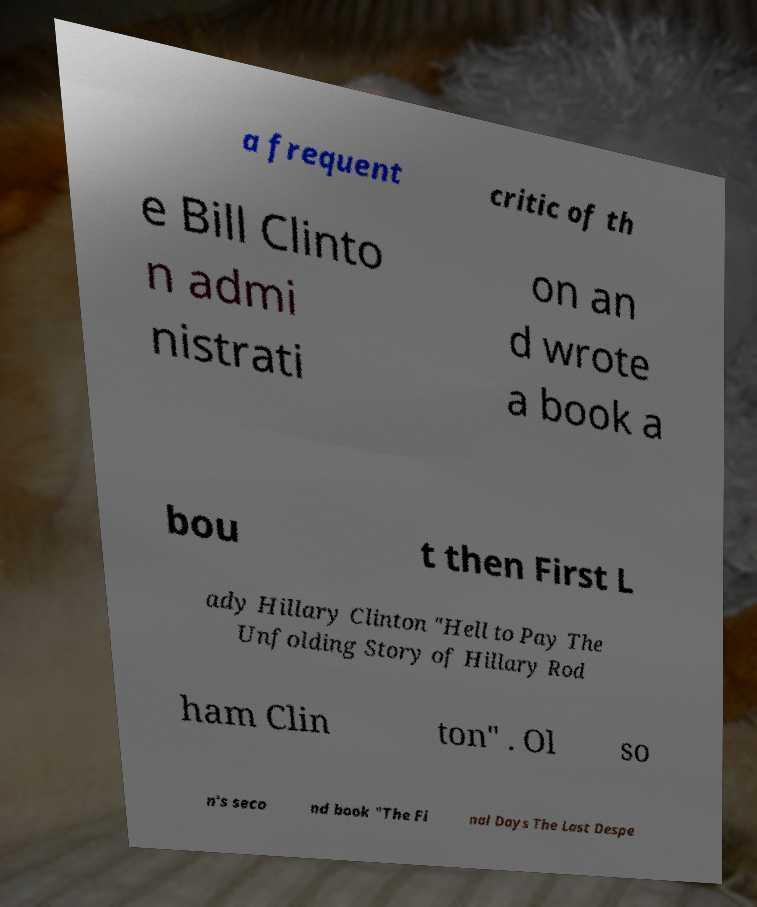Could you extract and type out the text from this image? a frequent critic of th e Bill Clinto n admi nistrati on an d wrote a book a bou t then First L ady Hillary Clinton "Hell to Pay The Unfolding Story of Hillary Rod ham Clin ton" . Ol so n's seco nd book "The Fi nal Days The Last Despe 